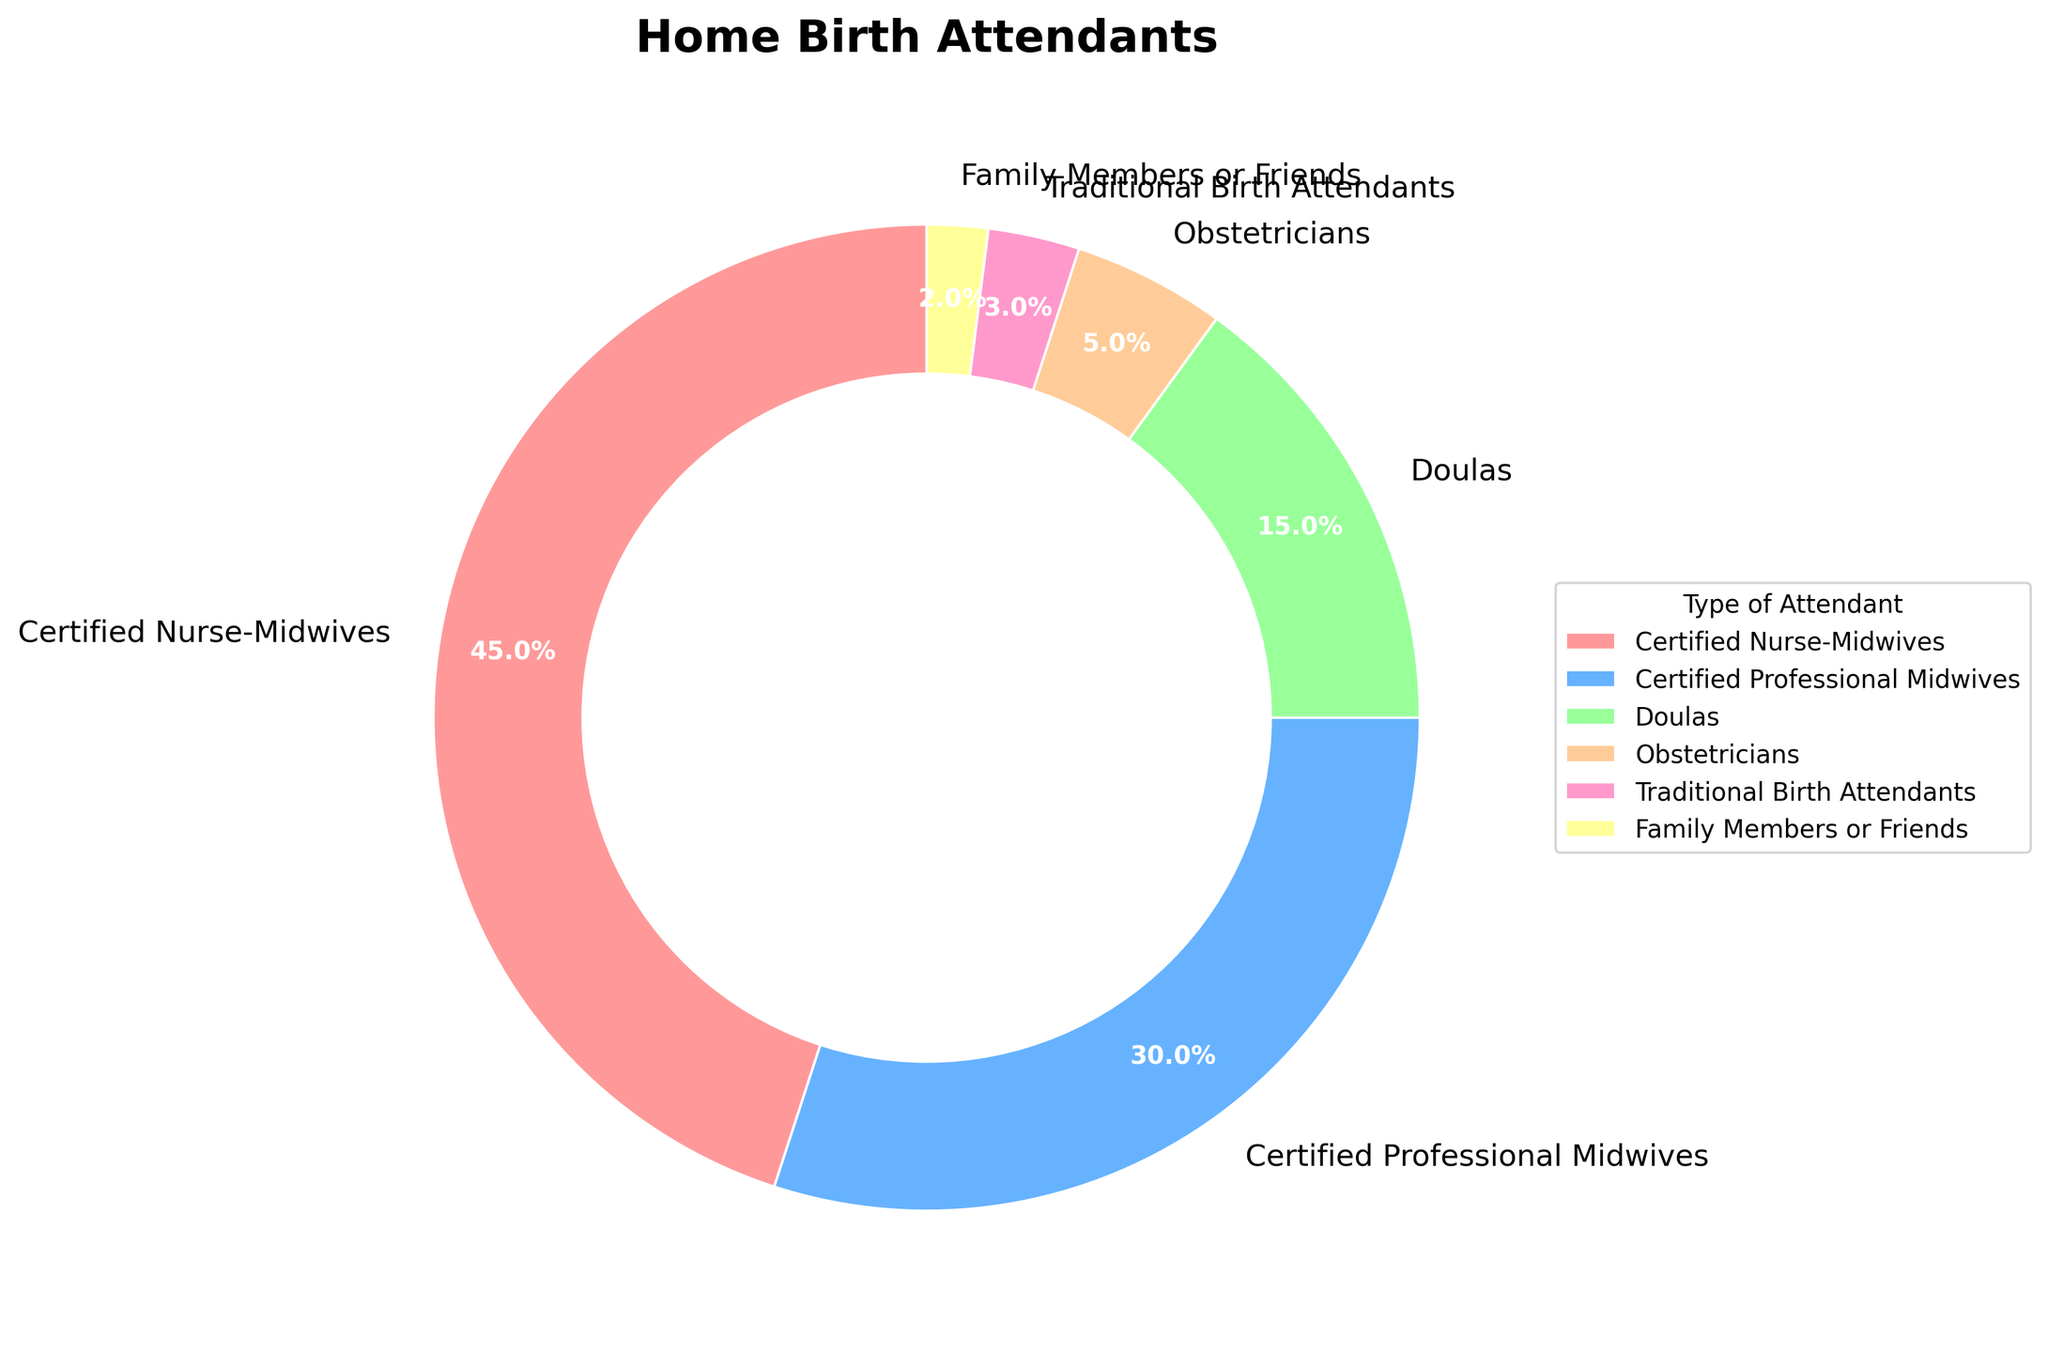What's the most common type of home birth attendant? The largest slice of the pie chart, representing 45%, is labeled as Certified Nurse-Midwives, indicating that they are the most common type of home birth attendant.
Answer: Certified Nurse-Midwives Which two types of attendants make up half of the total percentage? Certified Nurse-Midwives (45%) and Certified Professional Midwives (30%) together sum up to 75%. To find the two that make up 50%, we look for the largest segments that add up close to 50%. Certified Nurse-Midwives (45%) and Doulas (15%) together make up exactly 60%, overshooting our target. By excluding one of them and including the next largest category (Certified Professional Midwives - 30%), one can add Certified Nurse Midwives (45%) and Traditional Birth Attendants (3%) to get closer percentages. However, this leaves a composition sum of less than required. Upon trial and error combining largest two yields <of Nurse-Midwives (45%) and the lesser Professional (30%) totals dominant among top values>..
Answer: Certified Nurse-Midwives and Certified Professional Midwives Are there more doulas or obstetricians attending home births? We compare the percentage for Doulas (15%) versus Obstetricians (5%). Since 15% is greater than 5%, there are more doulas attending home births.
Answer: Doulas Which segment represents the smallest percentage, and what is it? The smallest segment of the pie chart, representing 2%, is labeled as Family Members or Friends.
Answer: Family Members or Friends at 2% How much greater is the percentage of Certified Nurse-Midwives compared to Doulas? To find the difference between the percentages of Certified Nurse-Midwives (45%) and Doulas (15%), we subtract 15 from 45. This equals a difference of 30%.
Answer: 30% Add the percentage of Traditional Birth Attendants and Family Members or Friends. What is their total contribution? The percentages are 3% and 2%, respectively. Adding these gives a total of 3 + 2 = 5%.
Answer: 5% Arrange the attendants by percentage in descending order. By simply ordering the provided percentages from highest to lowest: Certified Nurse-Midwives (45%), Certified Professional Midwives (30%), Doulas (15%), Obstetricians (5%), Traditional Birth Attendants (3%), and Family Members or Friends (2%).
Answer: Certified Nurse-Midwives, Certified Professional Midwives, Doulas, Obstetricians, Traditional Birth Attendants, Family Members or Friends Which color represents the Certified Professional Midwives? Referring to the color palette, Certified Professional Midwives are marked by the blue color slice in the pie chart.
Answer: Blue If you combine the percentages of obstetricians and Certified Professional Midwives, what do you get? Summing up the percentages of Obstetricians (5%) and Certified Professional Midwives (30%) gives 5 + 30 = 35%.
Answer: 35% What is the difference between the largest and smallest percentages shown in the chart? The largest percentage is 45% (Certified Nurse-Midwives) and the smallest is 2% (Family Members or Friends). The difference is 45 - 2 = 43%.
Answer: 43% 